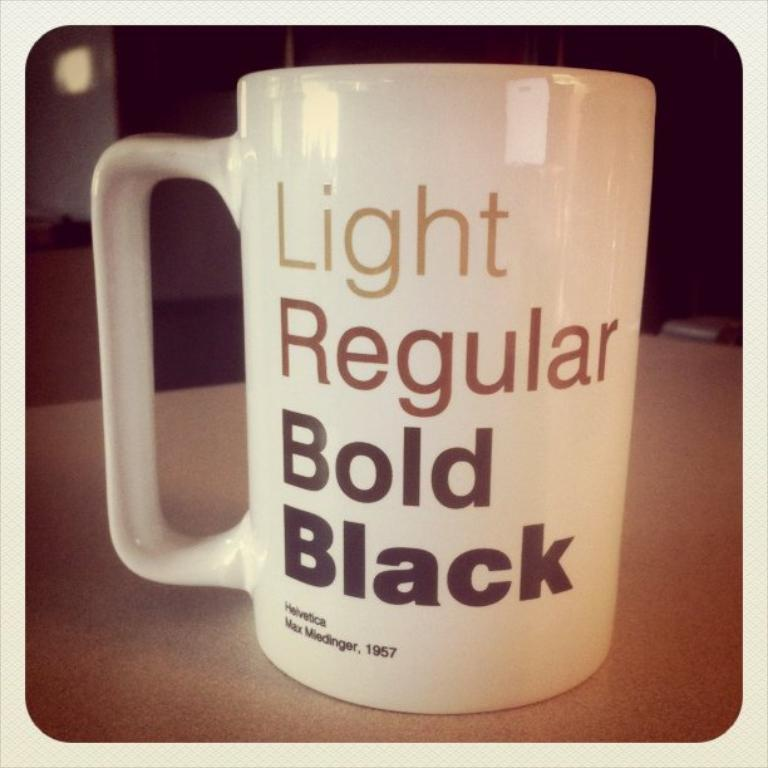Provide a one-sentence caption for the provided image. A coffee cup that has different flavors printed on it. 